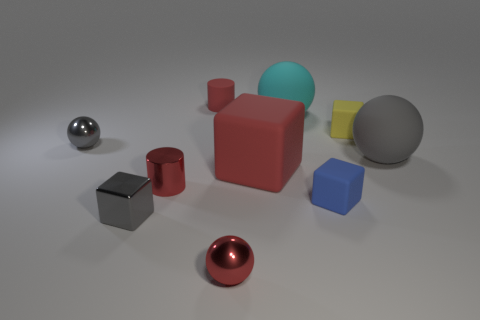Subtract all big red blocks. How many blocks are left? 3 Subtract all cyan spheres. How many spheres are left? 3 Subtract all cylinders. How many objects are left? 8 Subtract all gray blocks. How many gray balls are left? 2 Subtract 1 cylinders. How many cylinders are left? 1 Subtract 0 green spheres. How many objects are left? 10 Subtract all blue spheres. Subtract all brown cubes. How many spheres are left? 4 Subtract all tiny yellow matte things. Subtract all large cyan things. How many objects are left? 8 Add 5 gray spheres. How many gray spheres are left? 7 Add 4 gray rubber spheres. How many gray rubber spheres exist? 5 